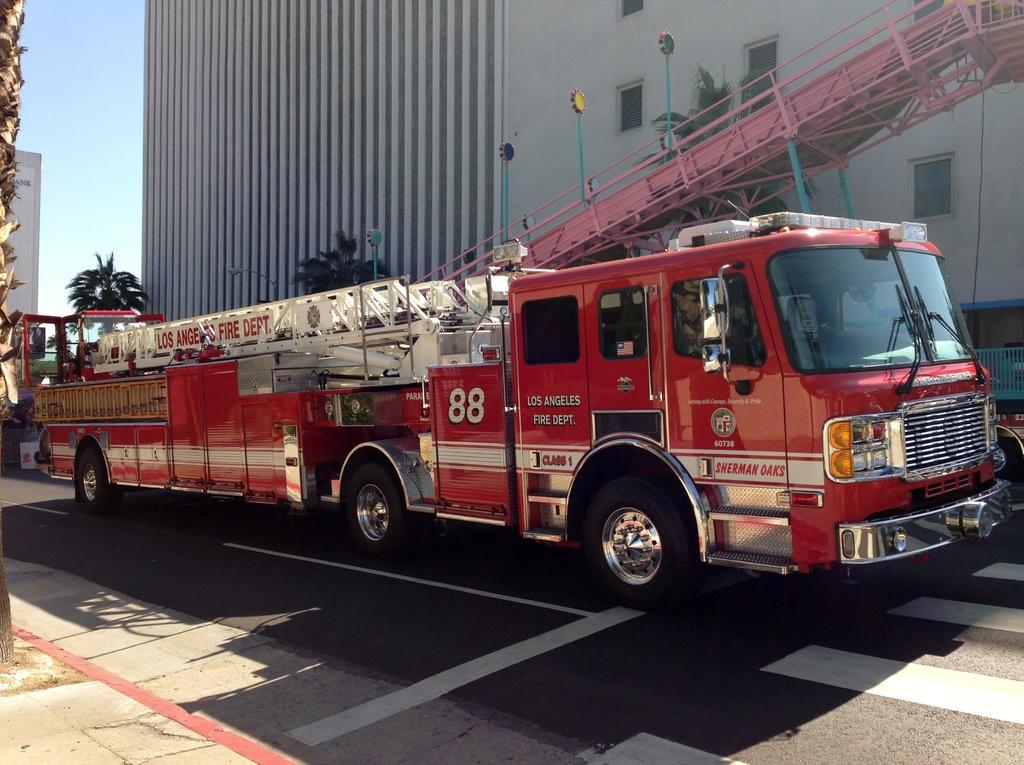What type of vehicle is in the image? There is a red color vehicle in the image. Where is the vehicle located? The vehicle is on the road. How is the vehicle positioned in the image? The vehicle is in the middle of the picture. What can be seen in the background of the image? There is a building and trees in the background of the image. What type of toothbrush is hanging from the vehicle in the image? There is no toothbrush present in the image. How does the mist affect the visibility of the vehicle in the image? There is no mention of mist in the image, so its effect on visibility cannot be determined. 